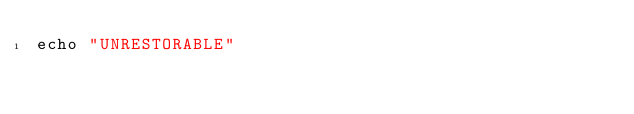<code> <loc_0><loc_0><loc_500><loc_500><_Nim_>echo "UNRESTORABLE"</code> 